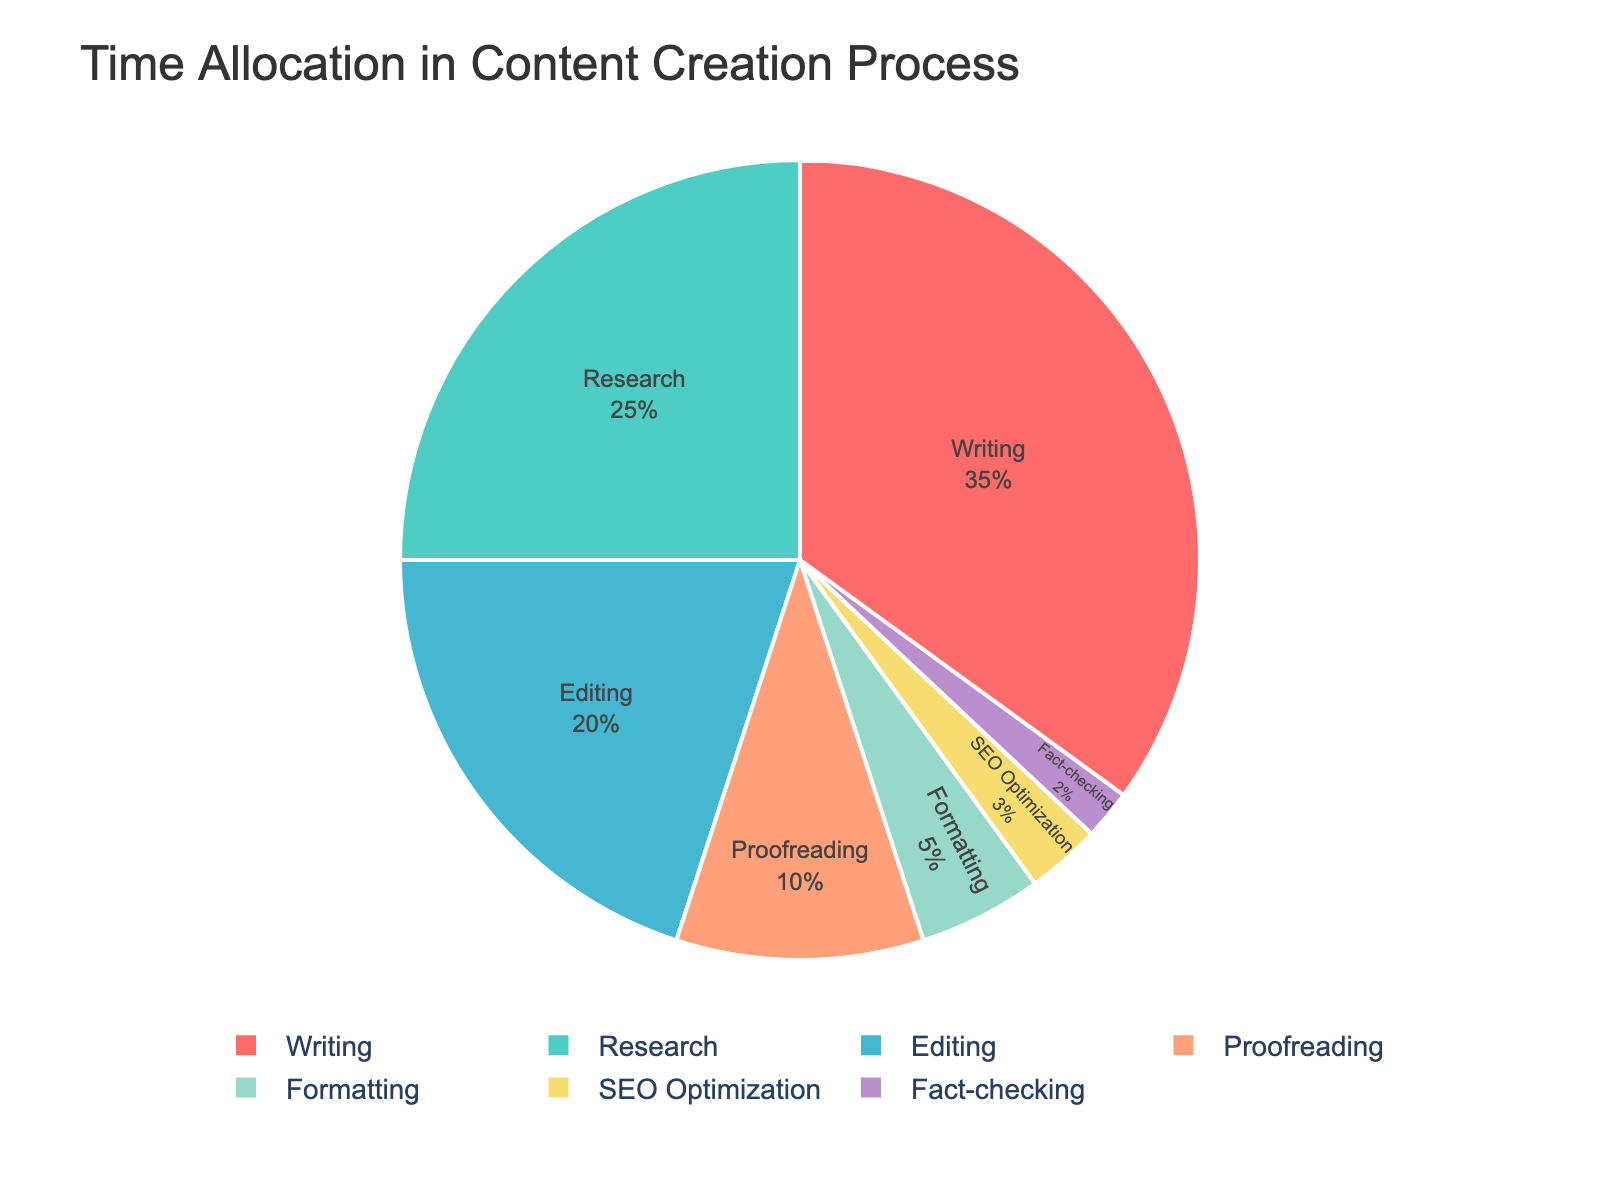What's the most time-consuming stage in the content creation process? By looking at the pie chart, the largest segment represents the stage with the highest percentage. In this case, writing takes up 35% of the total time, making it the most time-consuming stage.
Answer: Writing What's the combined percentage of time spent on research, editing, and proofreading? To find the combined percentage, sum the individual percentages for research (25%), editing (20%), and proofreading (10%). So, 25 + 20 + 10 = 55%.
Answer: 55% Which stages take less time than proofreading? The pie chart shows that proofreading takes 10% of the time. We need to find all stages with a smaller percentage: formatting (5%), SEO optimization (3%), and fact-checking (2%).
Answer: Formatting, SEO Optimization, Fact-checking What's the difference in time allocation between writing and editing? Writing takes 35% and editing takes 20% of the time. The difference between these two percentages is 35 - 20 = 15%.
Answer: 15% What's the total time allocated to SEO optimization and fact-checking? SEO optimization takes 3% of the time, and fact-checking takes 2%. The sum of these percentages is 3% + 2% = 5%.
Answer: 5% Which stage is represented by the light green color? From the color details provided in the code, we can infer that the stage associated with the light green color (#4ECDC4) is writing. The pie chart visually matches this information.
Answer: Writing Out of research and formatting, which stage takes more time? By comparing percentages directly from the pie chart, research takes 25% while formatting takes only 5%. Therefore, research takes more time.
Answer: Research How much more time is allocated to editing compared to SEO optimization and fact-checking combined? Editing takes 20% of the time. SEO optimization and fact-checking together take 3% + 2% = 5%. The difference is 20% - 5% = 15%.
Answer: 15% What's the relative proportion of time spent on proofreading to formatting? Proofreading occupies 10% and formatting occupies 5%. To find the relative proportion, divide 10 by 5, resulting in a ratio of 2:1.
Answer: 2:1 